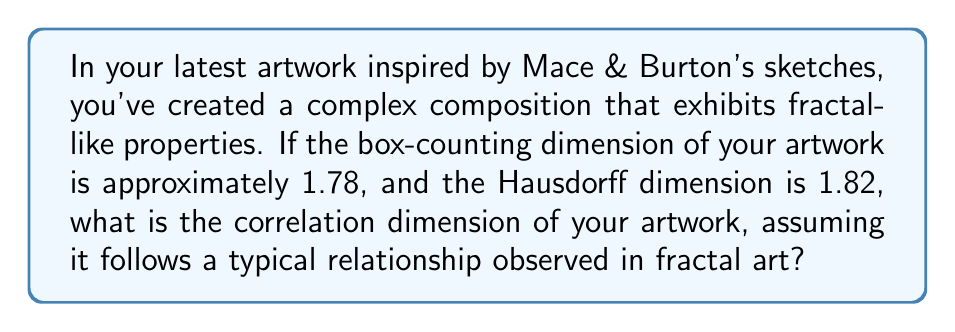Show me your answer to this math problem. To solve this problem, we need to understand the relationship between different fractal dimensions in complex artwork compositions. Let's approach this step-by-step:

1) In fractal geometry, there are several ways to measure dimension, including box-counting dimension ($D_B$), Hausdorff dimension ($D_H$), and correlation dimension ($D_C$).

2) For most fractal structures, including complex artworks, these dimensions are related, but not always equal. Typically, we observe:

   $$D_C \leq D_B \leq D_H$$

3) In this case, we're given:
   $D_B = 1.78$ (box-counting dimension)
   $D_H = 1.82$ (Hausdorff dimension)

4) In fractal art analysis, it's often observed that the correlation dimension is approximately the average of the box-counting and Hausdorff dimensions. This relationship can be expressed as:

   $$D_C \approx \frac{D_B + D_H}{2}$$

5) Substituting our known values:

   $$D_C \approx \frac{1.78 + 1.82}{2}$$

6) Calculating:

   $$D_C \approx \frac{3.60}{2} = 1.80$$

Therefore, based on the typical relationships observed in fractal art, the correlation dimension of your artwork is approximately 1.80.
Answer: 1.80 